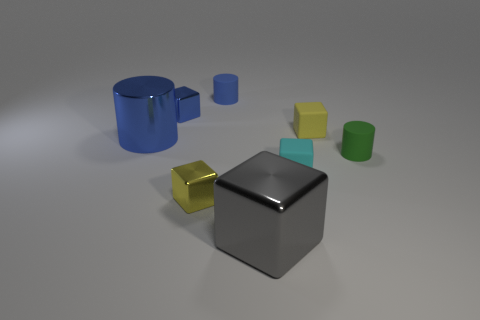What number of other things are the same material as the blue cube?
Give a very brief answer. 3. The thing that is on the right side of the large gray metallic thing and behind the large blue shiny cylinder has what shape?
Your answer should be very brief. Cube. What is the color of the rubber block that is to the left of the yellow thing behind the big blue shiny cylinder?
Give a very brief answer. Cyan. What shape is the large thing on the right side of the rubber thing that is behind the tiny shiny object that is behind the green cylinder?
Give a very brief answer. Cube. There is a matte thing that is both in front of the tiny blue rubber cylinder and left of the small yellow matte cube; how big is it?
Make the answer very short. Small. How many other matte cylinders are the same color as the big cylinder?
Provide a short and direct response. 1. There is another tiny cylinder that is the same color as the shiny cylinder; what is its material?
Your response must be concise. Rubber. What is the material of the tiny cyan object?
Offer a very short reply. Rubber. Do the small yellow thing to the left of the gray metallic cube and the small blue block have the same material?
Your response must be concise. Yes. There is a tiny green object in front of the big blue metal object; what is its shape?
Offer a terse response. Cylinder. 